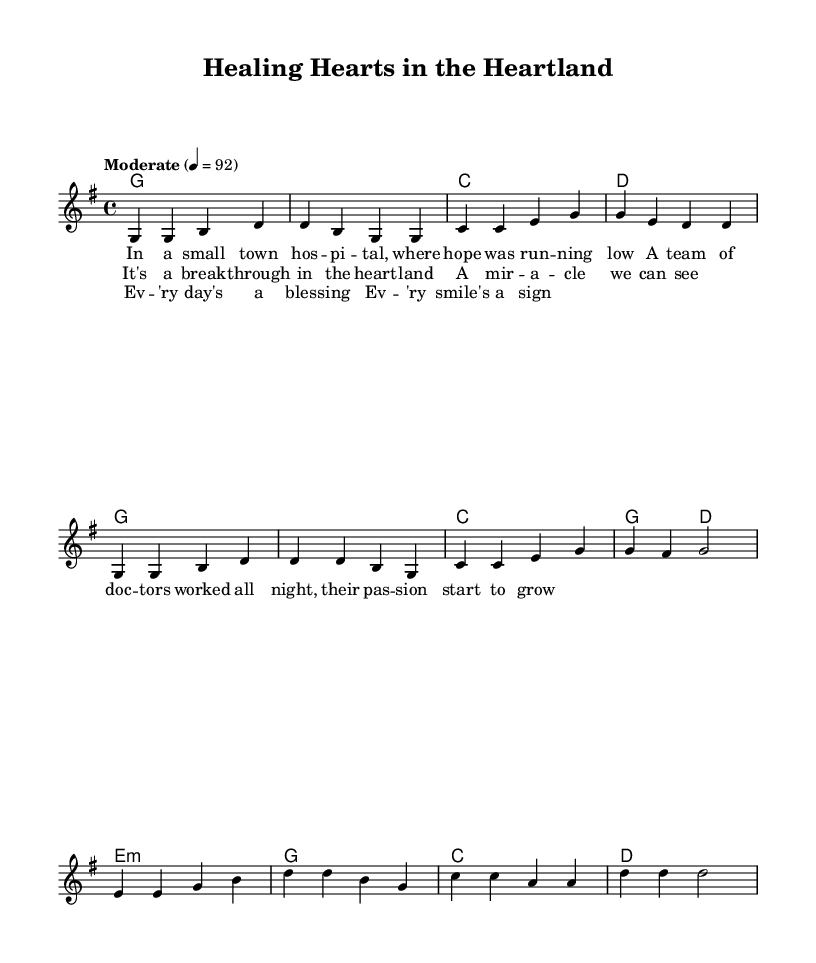What is the key signature of this music? The key signature is G major, which has one sharp. This is indicated at the beginning of the score.
Answer: G major What is the time signature of this music? The time signature is 4/4, which means there are four beats per measure. This is also indicated at the beginning of the score.
Answer: 4/4 What is the tempo marking of the piece? The tempo marking is "Moderate" with a tempo of 92 beats per minute, found in the global section of the score.
Answer: Moderate 92 How many measures are in the verse? The verse consists of 4 measures, which can be counted in the melody section as there are four distinct groupings of notes before the chorus begins.
Answer: 4 Which section of the song includes the lyrics "It's a break-through in the heart-land"? This lyric is found in the chorus, as indicated by the labeled lyric section following the melody.
Answer: Chorus What do the lyrics of the bridge express? The lyrics of the bridge express themes of gratitude and positivity, with phrases like "Ev'ry day's a blessing" and "Ev'ry smile's a sign". This content reflects an uplifting sentiment commonly found in country music.
Answer: Gratitude and positivity 